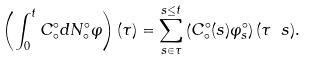<formula> <loc_0><loc_0><loc_500><loc_500>\left ( \int _ { 0 } ^ { t } C _ { \circ } ^ { \circ } d N _ { \circ } ^ { \circ } \varphi \right ) ( \tau ) = \sum _ { s \in \tau } ^ { s \leq t } \left ( C _ { \circ } ^ { \circ } ( s ) \varphi _ { s } ^ { \circ } \right ) ( \tau \ s ) .</formula> 